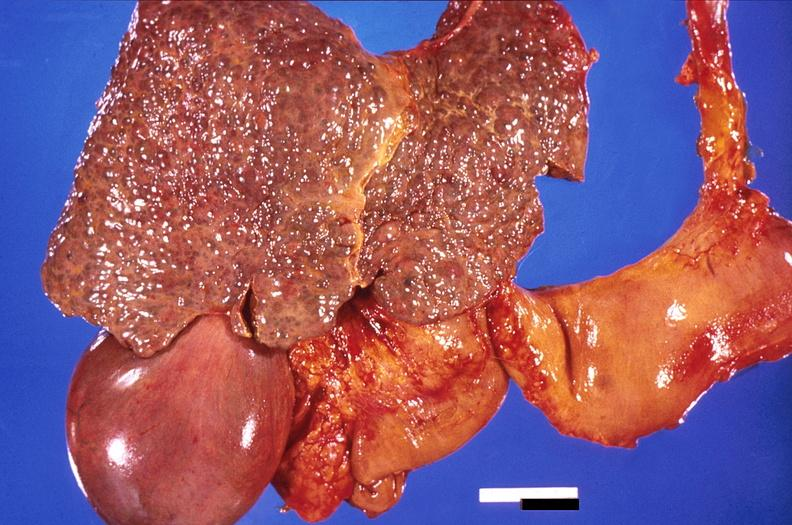what does this image show?
Answer the question using a single word or phrase. Liver 